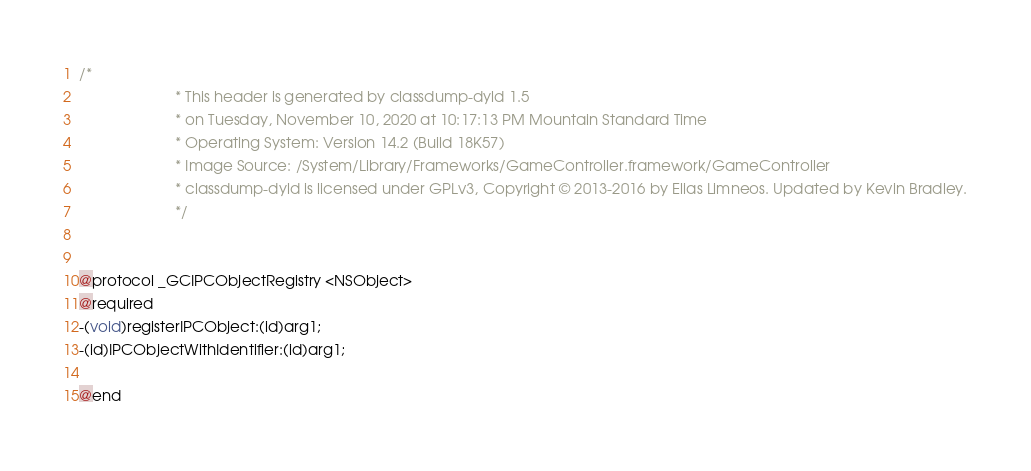<code> <loc_0><loc_0><loc_500><loc_500><_C_>/*
                       * This header is generated by classdump-dyld 1.5
                       * on Tuesday, November 10, 2020 at 10:17:13 PM Mountain Standard Time
                       * Operating System: Version 14.2 (Build 18K57)
                       * Image Source: /System/Library/Frameworks/GameController.framework/GameController
                       * classdump-dyld is licensed under GPLv3, Copyright © 2013-2016 by Elias Limneos. Updated by Kevin Bradley.
                       */


@protocol _GCIPCObjectRegistry <NSObject>
@required
-(void)registerIPCObject:(id)arg1;
-(id)IPCObjectWithIdentifier:(id)arg1;

@end

</code> 